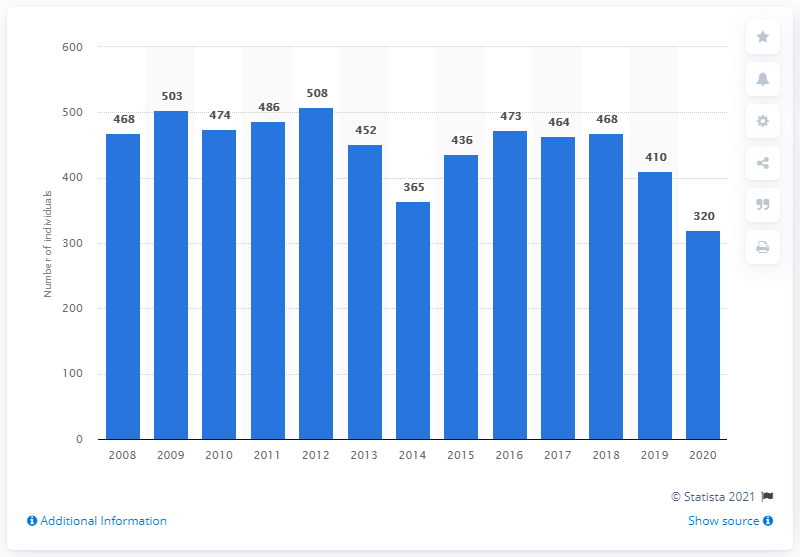List a handful of essential elements in this visual. In 2014, there were 365 individuals housed in Italy's youth detention centers. In 2020, there were 320 individuals detained in Italy's youth detention centers. 